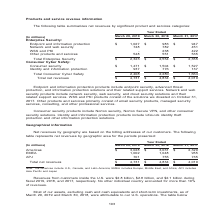According to Nortonlifelock's financial document, What is the revenue from customers inside the U.S. in fiscal 2019? According to the financial document, $2.8 billion. The relevant text states: "Revenues from customers inside the U.S. were $2.8 billion, $2.8 billion, and $2.1 billion during fiscal 2019, 2018, and 2017, respectively. No other individu Revenues from customers inside the U.S. we..." Also, What are the regions included in the table? The document contains multiple relevant values: Americas, EMEA, APJ. From the document: "Americas $ 3,028 $ 3,031 $ 2,329 EMEA 1,002 1,048 955 APJ 701 755 735 icas $ 3,028 $ 3,031 $ 2,329 EMEA 1,002 1,048 955 APJ 701 755 735 Americas $ 3,0..." Also, What areas are included in the Americas? U.S., Canada, and Latin America. The document states: "Note: The Americas include U.S., Canada, and Latin America; EMEA includes Europe, Middle East, and Africa; APJ includes Asia Pacific and Japan..." Also, can you calculate: What is the average revenue from customers inside the U.S. for fiscal years 2019, 2018 and 2017?  To answer this question, I need to perform calculations using the financial data. The calculation is: (2.8+2.8+2.1)/3, which equals 2.57 (in billions). This is based on the information: "Revenues from customers inside the U.S. were $2.8 billion, $2.8 billion, and $2.1 billion during fiscal 2019, 2018, and 2017, respectively. No other Revenues from customers inside the U.S. were $2.8 b..." The key data points involved are: 2.1, 2.8. Also, can you calculate: What is the Revenues from customers inside the U.S. expressed as a percentage of Total net revenues for 2019? Based on the calculation: 2.8 billion /4,731 million, the result is 59.18 (percentage). This is based on the information: "Total net revenues $ 4,731 $ 4,834 $ 4,019 Revenues from customers inside the U.S. were $2.8 billion, $2.8 billion, and $2.1 billion during fiscal 2019, 2018, and 2017, respectively. No other Revenues..." The key data points involved are: 2.8, 4,731. Also, can you calculate: What is the average Total net revenues for fiscal years 2019, 2018 and 2017? To answer this question, I need to perform calculations using the financial data. The calculation is: (4,731+4,834+4,019)/3, which equals 4528 (in millions). This is based on the information: "Total net revenues $ 4,731 $ 4,834 $ 4,019 Total net revenues $ 4,731 $ 4,834 $ 4,019 Total net revenues $ 4,731 $ 4,834 $ 4,019..." The key data points involved are: 4,019, 4,731, 4,834. 